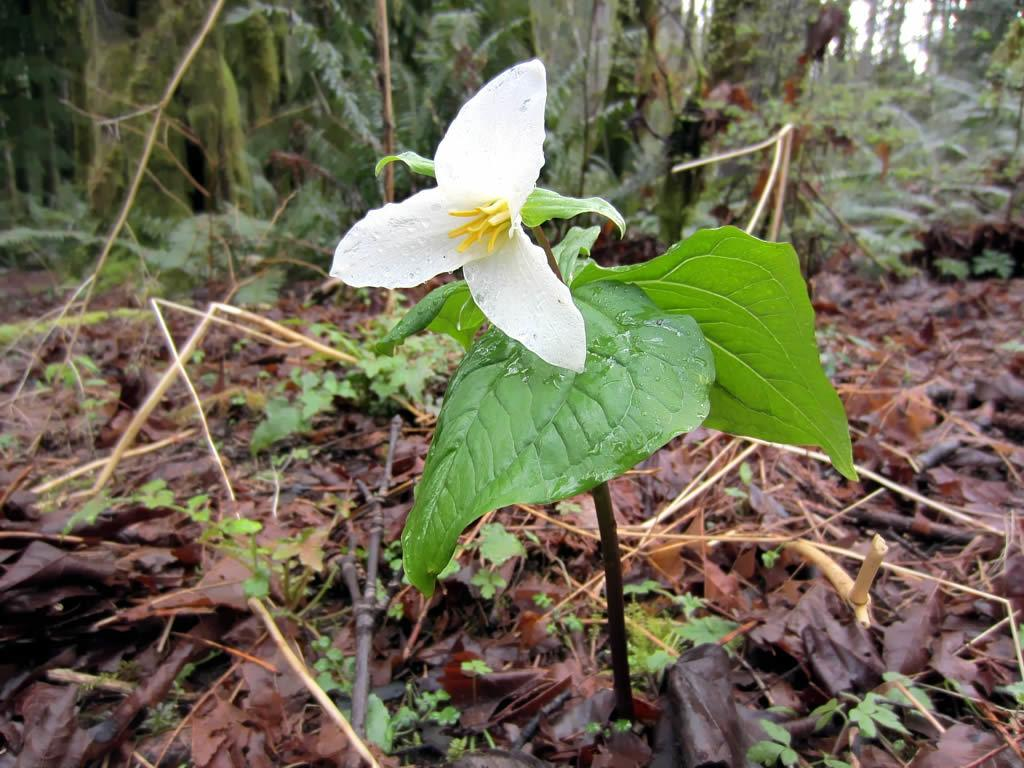What is the main subject in the center of the image? There is a plant in the center of the image. What can be observed about the plant's flower? The plant has a white flower. What is the condition of the plant's leaves? The plant has dry leaves. What can be seen in the background of the image? There are trees and sticks in the background of the image. What type of paste is being used to hold the memory in the image? There is no paste or memory present in the image; it features a plant with a white flower and dry leaves. What emotion is displayed by the plant in the image? Plants do not display emotions like disgust; they are inanimate objects. 